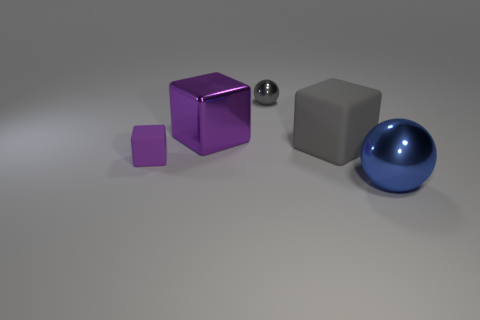Is there a large thing of the same color as the tiny matte block?
Your answer should be very brief. Yes. Is there a large gray rubber thing?
Your answer should be compact. Yes. There is a tiny object on the left side of the gray ball; what is its color?
Provide a short and direct response. Purple. There is a gray metallic sphere; does it have the same size as the metal sphere that is on the right side of the big gray object?
Provide a short and direct response. No. What size is the object that is both to the left of the blue metal object and on the right side of the small gray shiny ball?
Your response must be concise. Large. Is there a object that has the same material as the large purple cube?
Give a very brief answer. Yes. There is a tiny purple thing; what shape is it?
Make the answer very short. Cube. Do the gray ball and the blue metallic sphere have the same size?
Ensure brevity in your answer.  No. What number of other things are the same shape as the gray metal object?
Keep it short and to the point. 1. What is the shape of the large metal thing to the left of the blue object?
Provide a short and direct response. Cube. 